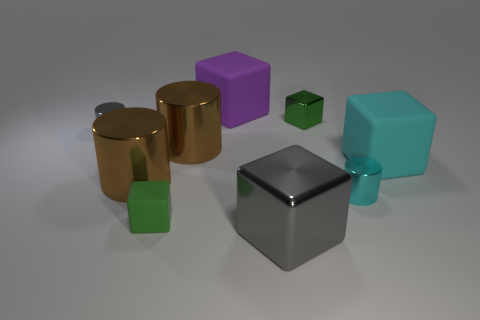What shape is the cyan matte thing?
Keep it short and to the point. Cube. There is a matte cube right of the tiny cube that is behind the tiny gray metallic cylinder; what size is it?
Your answer should be compact. Large. How many objects are gray shiny cylinders or cyan things?
Your answer should be very brief. 3. Is the purple object the same shape as the large cyan object?
Your answer should be very brief. Yes. Are there any green objects that have the same material as the tiny gray cylinder?
Offer a very short reply. Yes. Is there a large shiny cube that is on the left side of the gray object behind the cyan block?
Ensure brevity in your answer.  No. Do the green object that is in front of the cyan rubber cube and the small cyan metal object have the same size?
Ensure brevity in your answer.  Yes. What is the size of the green matte object?
Your response must be concise. Small. Is there a cube that has the same color as the small rubber object?
Give a very brief answer. Yes. What number of small things are green matte things or cyan rubber blocks?
Make the answer very short. 1. 